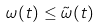<formula> <loc_0><loc_0><loc_500><loc_500>\omega ( t ) \leq \tilde { \omega } ( t )</formula> 